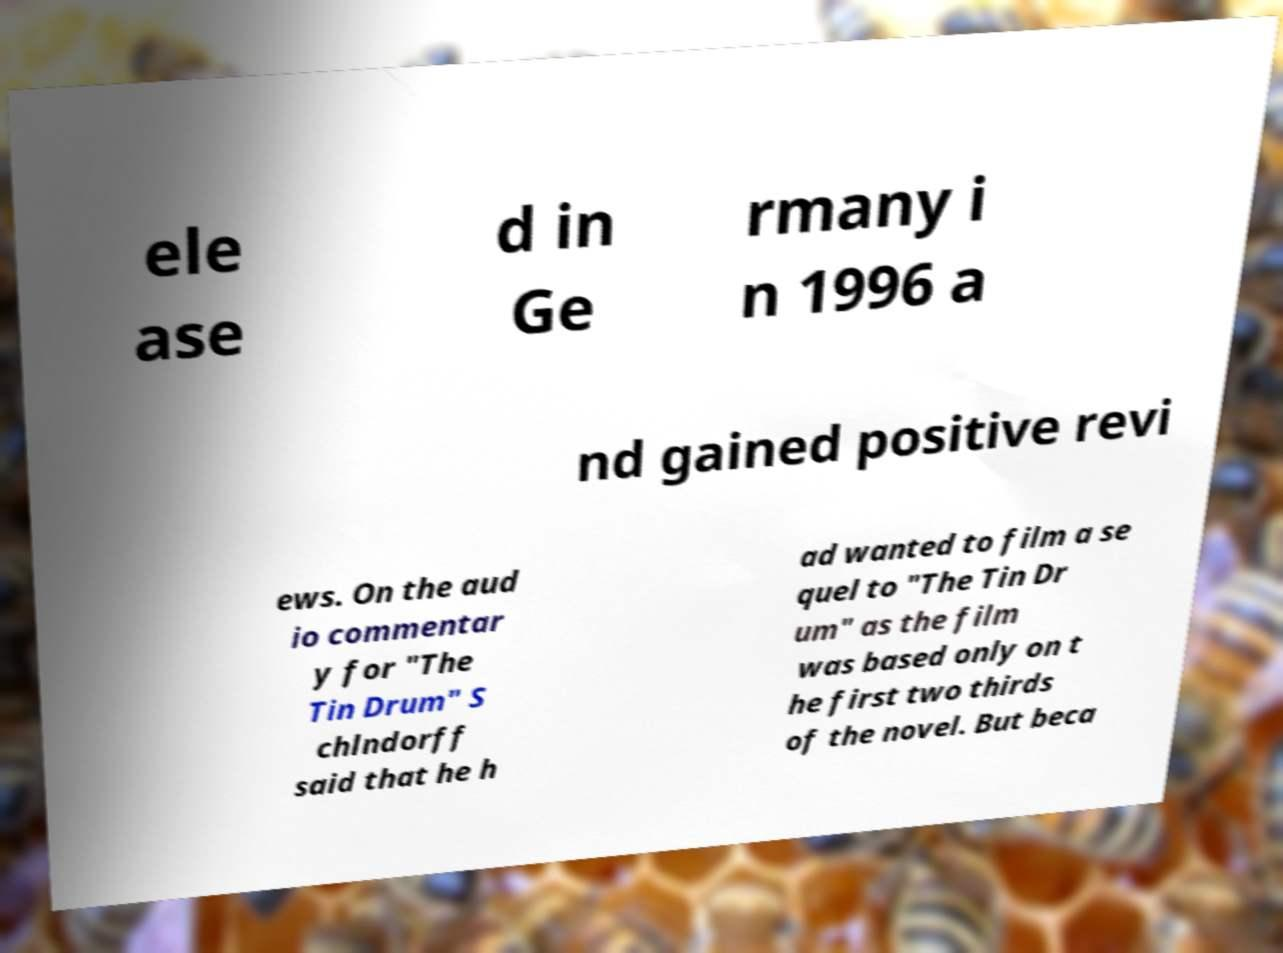What messages or text are displayed in this image? I need them in a readable, typed format. ele ase d in Ge rmany i n 1996 a nd gained positive revi ews. On the aud io commentar y for "The Tin Drum" S chlndorff said that he h ad wanted to film a se quel to "The Tin Dr um" as the film was based only on t he first two thirds of the novel. But beca 